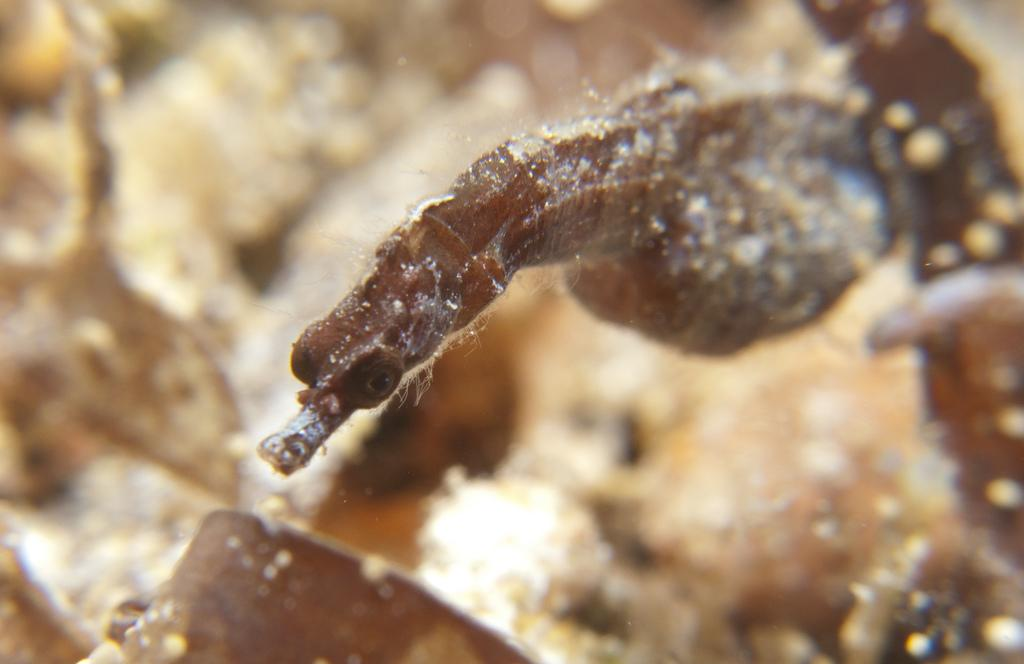What is the main subject of the image? There is a seahorse in the image. Can you describe the background of the image? The background of the image is blurry. How does the seahorse increase its speed in the image? The seahorse does not increase its speed in the image, as it is a static image and not a video. What type of lip can be seen on the seahorse in the image? There are no lips present on the seahorse in the image, as seahorses are marine creatures and do not have lips. 